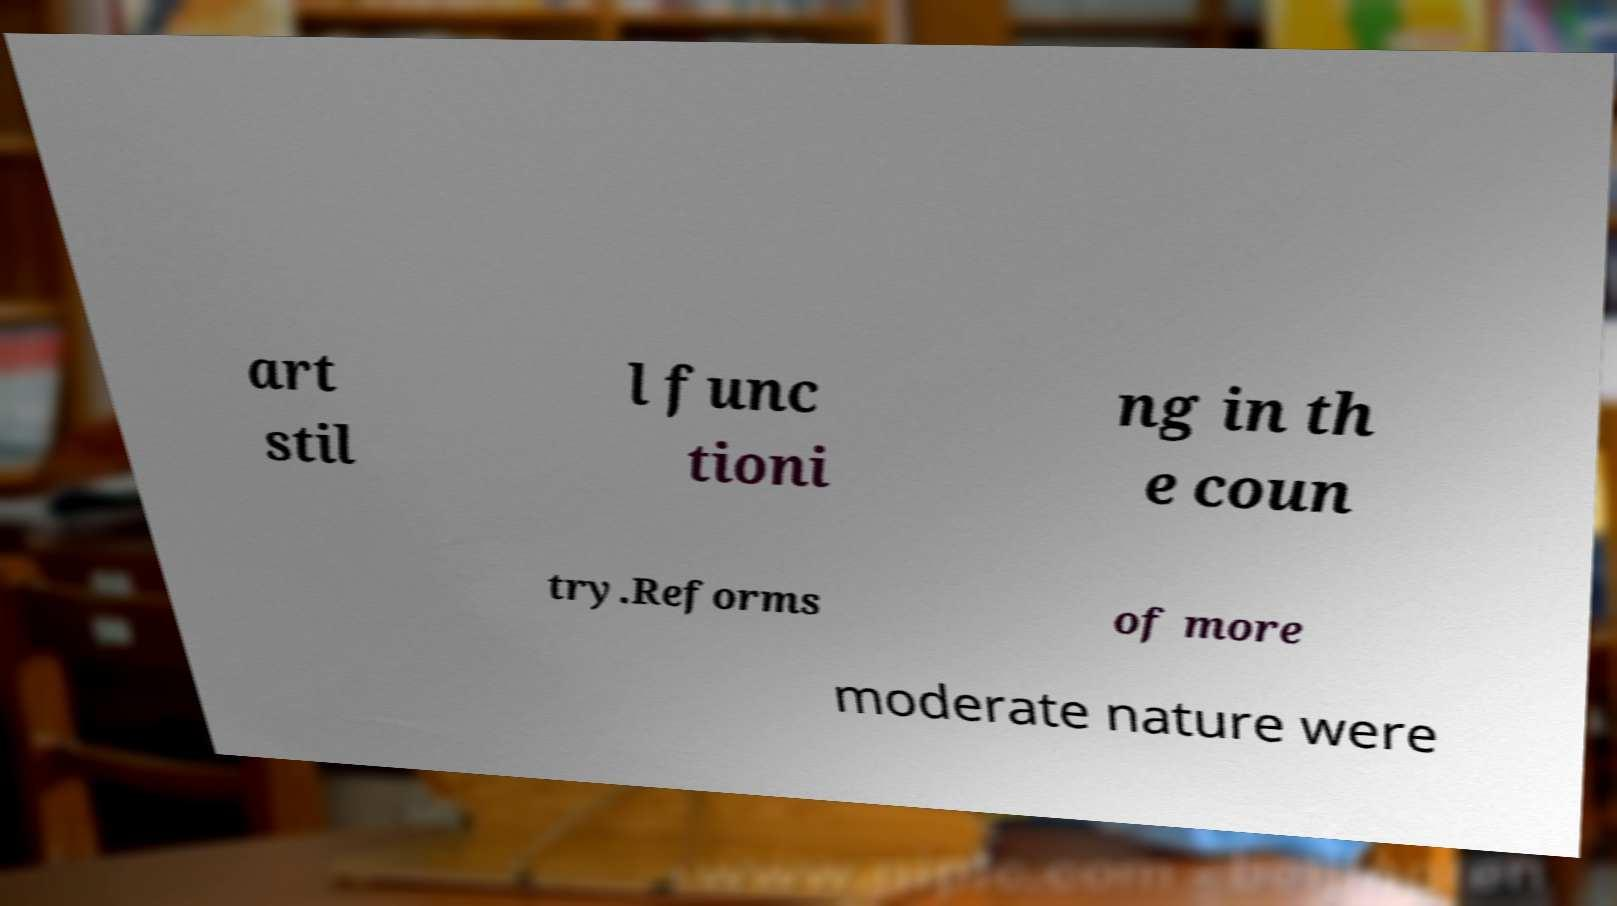Can you read and provide the text displayed in the image?This photo seems to have some interesting text. Can you extract and type it out for me? art stil l func tioni ng in th e coun try.Reforms of more moderate nature were 